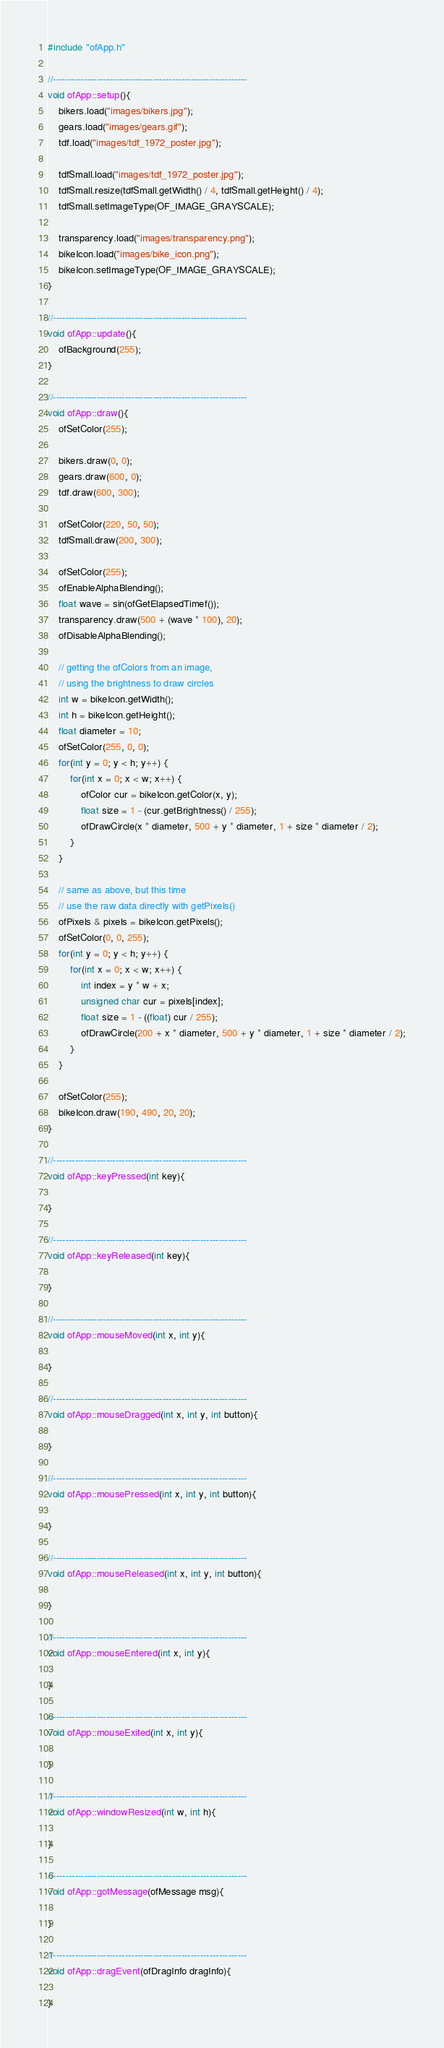Convert code to text. <code><loc_0><loc_0><loc_500><loc_500><_C++_>#include "ofApp.h"

//--------------------------------------------------------------
void ofApp::setup(){
	bikers.load("images/bikers.jpg");
	gears.load("images/gears.gif");
	tdf.load("images/tdf_1972_poster.jpg");

	tdfSmall.load("images/tdf_1972_poster.jpg");
	tdfSmall.resize(tdfSmall.getWidth() / 4, tdfSmall.getHeight() / 4);
	tdfSmall.setImageType(OF_IMAGE_GRAYSCALE);

	transparency.load("images/transparency.png");
	bikeIcon.load("images/bike_icon.png");
	bikeIcon.setImageType(OF_IMAGE_GRAYSCALE);
}

//--------------------------------------------------------------
void ofApp::update(){
	ofBackground(255);	
}

//--------------------------------------------------------------
void ofApp::draw(){	
	ofSetColor(255);

	bikers.draw(0, 0);
	gears.draw(600, 0);
	tdf.draw(600, 300);
	
	ofSetColor(220, 50, 50);
	tdfSmall.draw(200, 300);
	
	ofSetColor(255);
	ofEnableAlphaBlending();
	float wave = sin(ofGetElapsedTimef());
	transparency.draw(500 + (wave * 100), 20);
	ofDisableAlphaBlending();
	
	// getting the ofColors from an image,
	// using the brightness to draw circles
	int w = bikeIcon.getWidth();
	int h = bikeIcon.getHeight();
	float diameter = 10;
	ofSetColor(255, 0, 0);
	for(int y = 0; y < h; y++) {
		for(int x = 0; x < w; x++) {
			ofColor cur = bikeIcon.getColor(x, y);
			float size = 1 - (cur.getBrightness() / 255);
			ofDrawCircle(x * diameter, 500 + y * diameter, 1 + size * diameter / 2);
		}
	}
	
	// same as above, but this time
	// use the raw data directly with getPixels()
	ofPixels & pixels = bikeIcon.getPixels();
	ofSetColor(0, 0, 255);
	for(int y = 0; y < h; y++) {
		for(int x = 0; x < w; x++) {
			int index = y * w + x;
			unsigned char cur = pixels[index];
			float size = 1 - ((float) cur / 255);
			ofDrawCircle(200 + x * diameter, 500 + y * diameter, 1 + size * diameter / 2);
		}
	}
	
	ofSetColor(255);
	bikeIcon.draw(190, 490, 20, 20);
}

//--------------------------------------------------------------
void ofApp::keyPressed(int key){

}

//--------------------------------------------------------------
void ofApp::keyReleased(int key){

}

//--------------------------------------------------------------
void ofApp::mouseMoved(int x, int y){

}

//--------------------------------------------------------------
void ofApp::mouseDragged(int x, int y, int button){

}

//--------------------------------------------------------------
void ofApp::mousePressed(int x, int y, int button){

}

//--------------------------------------------------------------
void ofApp::mouseReleased(int x, int y, int button){

}

//--------------------------------------------------------------
void ofApp::mouseEntered(int x, int y){

}

//--------------------------------------------------------------
void ofApp::mouseExited(int x, int y){

}

//--------------------------------------------------------------
void ofApp::windowResized(int w, int h){

}

//--------------------------------------------------------------
void ofApp::gotMessage(ofMessage msg){

}

//--------------------------------------------------------------
void ofApp::dragEvent(ofDragInfo dragInfo){ 

}
</code> 